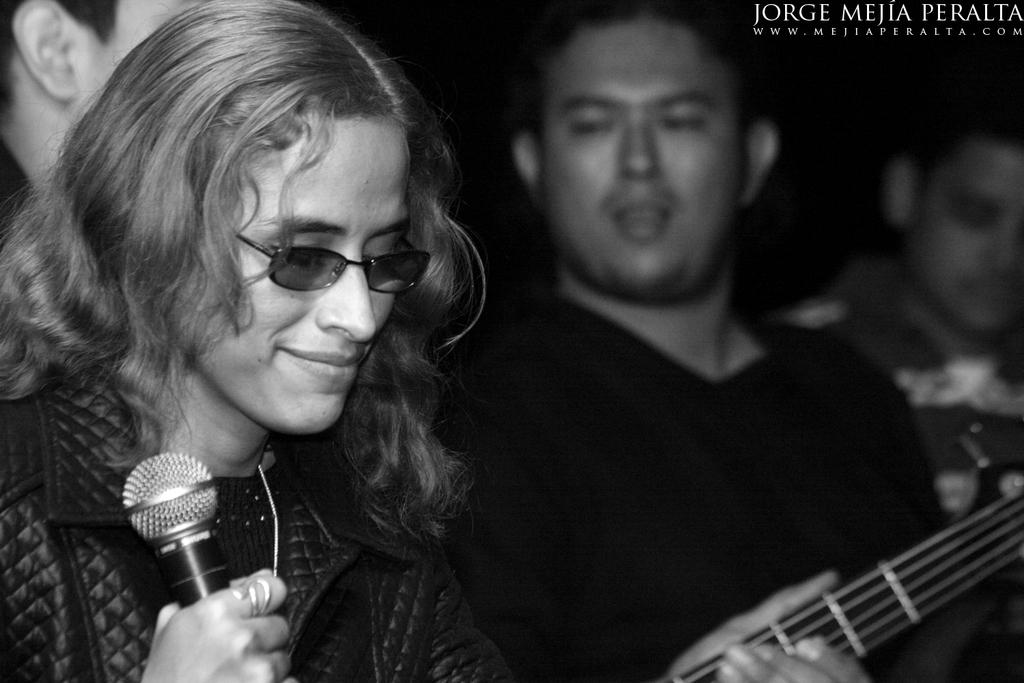How many people are in the image? There are persons in the image. What is one person doing in the image? One person is holding a microphone. Can you describe the appearance of the person holding the microphone? The person holding the microphone is wearing glasses and a coat. What is the color of the background in the image? The background of the image is dark. What type of hen can be seen in the image? There is no hen present in the image. Is the microphone made of silver in the image? The provided facts do not mention the material of the microphone, so it cannot be determined from the image. 